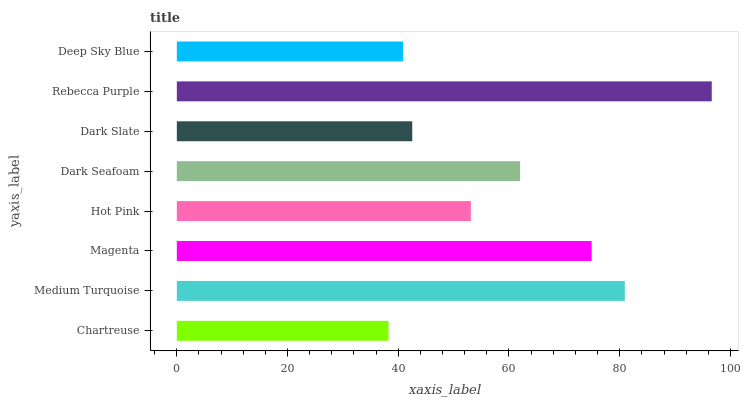Is Chartreuse the minimum?
Answer yes or no. Yes. Is Rebecca Purple the maximum?
Answer yes or no. Yes. Is Medium Turquoise the minimum?
Answer yes or no. No. Is Medium Turquoise the maximum?
Answer yes or no. No. Is Medium Turquoise greater than Chartreuse?
Answer yes or no. Yes. Is Chartreuse less than Medium Turquoise?
Answer yes or no. Yes. Is Chartreuse greater than Medium Turquoise?
Answer yes or no. No. Is Medium Turquoise less than Chartreuse?
Answer yes or no. No. Is Dark Seafoam the high median?
Answer yes or no. Yes. Is Hot Pink the low median?
Answer yes or no. Yes. Is Magenta the high median?
Answer yes or no. No. Is Chartreuse the low median?
Answer yes or no. No. 